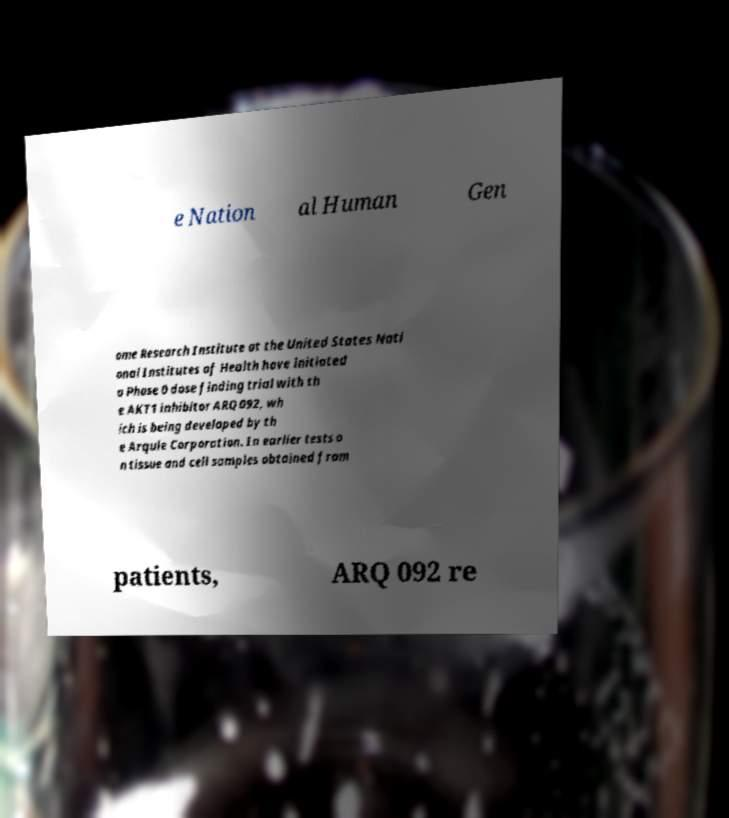I need the written content from this picture converted into text. Can you do that? e Nation al Human Gen ome Research Institute at the United States Nati onal Institutes of Health have initiated a Phase 0 dose finding trial with th e AKT1 inhibitor ARQ 092, wh ich is being developed by th e Arqule Corporation. In earlier tests o n tissue and cell samples obtained from patients, ARQ 092 re 